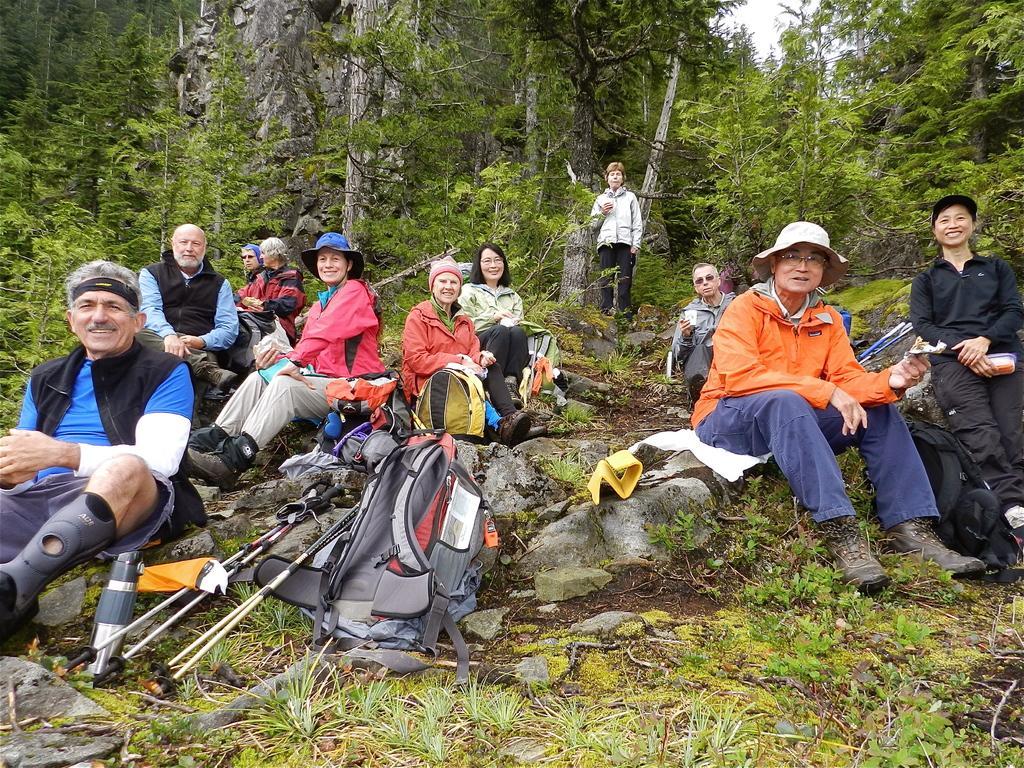Can you describe this image briefly? In the foreground, I can see a group of people on grass and I can see sticks and bags. In the background, I can see trees, mountains, one person is standing and the sky. This image taken, maybe in the forest. 